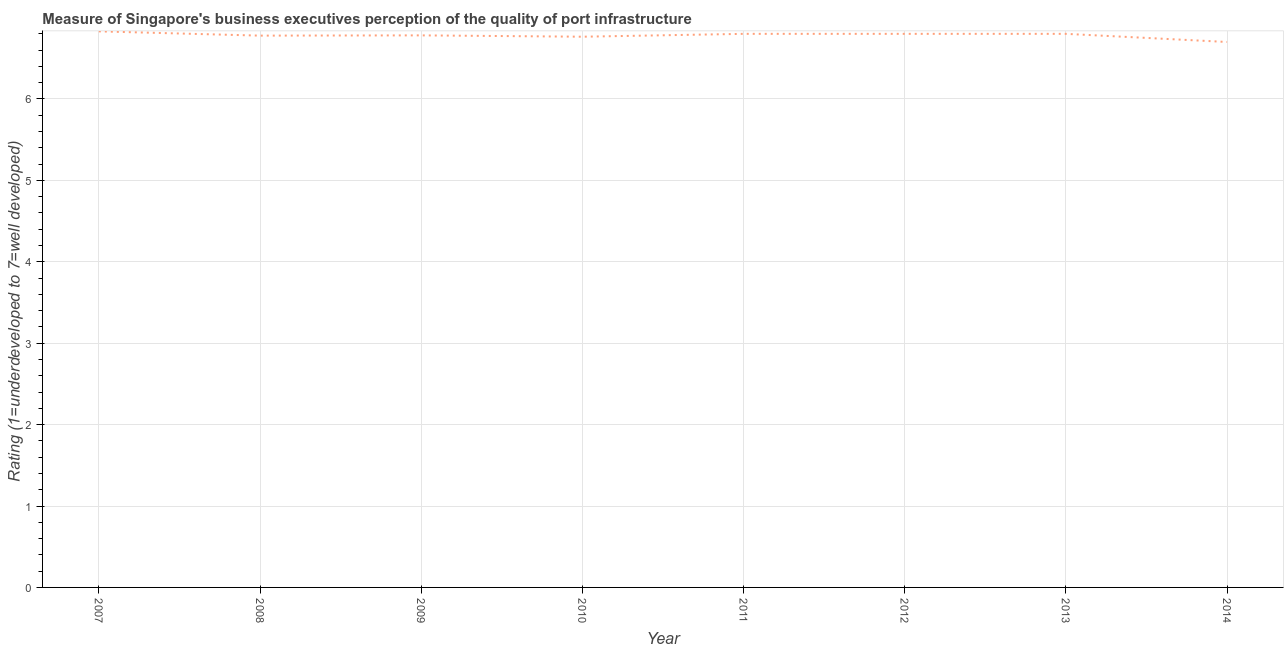Across all years, what is the maximum rating measuring quality of port infrastructure?
Offer a very short reply. 6.83. In which year was the rating measuring quality of port infrastructure maximum?
Ensure brevity in your answer.  2007. In which year was the rating measuring quality of port infrastructure minimum?
Offer a terse response. 2014. What is the sum of the rating measuring quality of port infrastructure?
Offer a very short reply. 54.25. What is the difference between the rating measuring quality of port infrastructure in 2009 and 2012?
Your response must be concise. -0.02. What is the average rating measuring quality of port infrastructure per year?
Make the answer very short. 6.78. What is the median rating measuring quality of port infrastructure?
Offer a very short reply. 6.79. Do a majority of the years between 2012 and 2014 (inclusive) have rating measuring quality of port infrastructure greater than 6 ?
Your answer should be very brief. Yes. What is the ratio of the rating measuring quality of port infrastructure in 2010 to that in 2012?
Keep it short and to the point. 0.99. Is the rating measuring quality of port infrastructure in 2007 less than that in 2012?
Your response must be concise. No. What is the difference between the highest and the second highest rating measuring quality of port infrastructure?
Your response must be concise. 0.03. What is the difference between the highest and the lowest rating measuring quality of port infrastructure?
Keep it short and to the point. 0.13. In how many years, is the rating measuring quality of port infrastructure greater than the average rating measuring quality of port infrastructure taken over all years?
Provide a succinct answer. 4. How many lines are there?
Offer a very short reply. 1. How many years are there in the graph?
Make the answer very short. 8. What is the difference between two consecutive major ticks on the Y-axis?
Keep it short and to the point. 1. Are the values on the major ticks of Y-axis written in scientific E-notation?
Give a very brief answer. No. Does the graph contain grids?
Provide a succinct answer. Yes. What is the title of the graph?
Offer a terse response. Measure of Singapore's business executives perception of the quality of port infrastructure. What is the label or title of the Y-axis?
Your response must be concise. Rating (1=underdeveloped to 7=well developed) . What is the Rating (1=underdeveloped to 7=well developed)  in 2007?
Your answer should be very brief. 6.83. What is the Rating (1=underdeveloped to 7=well developed)  of 2008?
Your answer should be very brief. 6.78. What is the Rating (1=underdeveloped to 7=well developed)  in 2009?
Give a very brief answer. 6.78. What is the Rating (1=underdeveloped to 7=well developed)  in 2010?
Your answer should be very brief. 6.76. What is the Rating (1=underdeveloped to 7=well developed)  of 2011?
Give a very brief answer. 6.8. What is the Rating (1=underdeveloped to 7=well developed)  in 2012?
Your answer should be compact. 6.8. What is the difference between the Rating (1=underdeveloped to 7=well developed)  in 2007 and 2008?
Give a very brief answer. 0.05. What is the difference between the Rating (1=underdeveloped to 7=well developed)  in 2007 and 2009?
Your response must be concise. 0.05. What is the difference between the Rating (1=underdeveloped to 7=well developed)  in 2007 and 2010?
Keep it short and to the point. 0.07. What is the difference between the Rating (1=underdeveloped to 7=well developed)  in 2007 and 2011?
Provide a short and direct response. 0.03. What is the difference between the Rating (1=underdeveloped to 7=well developed)  in 2007 and 2012?
Provide a short and direct response. 0.03. What is the difference between the Rating (1=underdeveloped to 7=well developed)  in 2007 and 2013?
Offer a very short reply. 0.03. What is the difference between the Rating (1=underdeveloped to 7=well developed)  in 2007 and 2014?
Provide a succinct answer. 0.13. What is the difference between the Rating (1=underdeveloped to 7=well developed)  in 2008 and 2009?
Your answer should be compact. -0. What is the difference between the Rating (1=underdeveloped to 7=well developed)  in 2008 and 2010?
Your answer should be very brief. 0.01. What is the difference between the Rating (1=underdeveloped to 7=well developed)  in 2008 and 2011?
Keep it short and to the point. -0.02. What is the difference between the Rating (1=underdeveloped to 7=well developed)  in 2008 and 2012?
Provide a short and direct response. -0.02. What is the difference between the Rating (1=underdeveloped to 7=well developed)  in 2008 and 2013?
Your response must be concise. -0.02. What is the difference between the Rating (1=underdeveloped to 7=well developed)  in 2008 and 2014?
Provide a succinct answer. 0.08. What is the difference between the Rating (1=underdeveloped to 7=well developed)  in 2009 and 2010?
Offer a terse response. 0.02. What is the difference between the Rating (1=underdeveloped to 7=well developed)  in 2009 and 2011?
Ensure brevity in your answer.  -0.02. What is the difference between the Rating (1=underdeveloped to 7=well developed)  in 2009 and 2012?
Offer a very short reply. -0.02. What is the difference between the Rating (1=underdeveloped to 7=well developed)  in 2009 and 2013?
Offer a terse response. -0.02. What is the difference between the Rating (1=underdeveloped to 7=well developed)  in 2009 and 2014?
Keep it short and to the point. 0.08. What is the difference between the Rating (1=underdeveloped to 7=well developed)  in 2010 and 2011?
Your response must be concise. -0.04. What is the difference between the Rating (1=underdeveloped to 7=well developed)  in 2010 and 2012?
Your answer should be compact. -0.04. What is the difference between the Rating (1=underdeveloped to 7=well developed)  in 2010 and 2013?
Keep it short and to the point. -0.04. What is the difference between the Rating (1=underdeveloped to 7=well developed)  in 2010 and 2014?
Offer a terse response. 0.06. What is the difference between the Rating (1=underdeveloped to 7=well developed)  in 2011 and 2012?
Provide a short and direct response. 0. What is the difference between the Rating (1=underdeveloped to 7=well developed)  in 2011 and 2014?
Give a very brief answer. 0.1. What is the difference between the Rating (1=underdeveloped to 7=well developed)  in 2012 and 2013?
Your response must be concise. 0. What is the difference between the Rating (1=underdeveloped to 7=well developed)  in 2012 and 2014?
Your answer should be very brief. 0.1. What is the ratio of the Rating (1=underdeveloped to 7=well developed)  in 2007 to that in 2008?
Give a very brief answer. 1.01. What is the ratio of the Rating (1=underdeveloped to 7=well developed)  in 2007 to that in 2010?
Offer a terse response. 1.01. What is the ratio of the Rating (1=underdeveloped to 7=well developed)  in 2007 to that in 2012?
Keep it short and to the point. 1. What is the ratio of the Rating (1=underdeveloped to 7=well developed)  in 2007 to that in 2013?
Offer a terse response. 1. What is the ratio of the Rating (1=underdeveloped to 7=well developed)  in 2007 to that in 2014?
Your answer should be very brief. 1.02. What is the ratio of the Rating (1=underdeveloped to 7=well developed)  in 2008 to that in 2009?
Your answer should be compact. 1. What is the ratio of the Rating (1=underdeveloped to 7=well developed)  in 2008 to that in 2011?
Your answer should be compact. 1. What is the ratio of the Rating (1=underdeveloped to 7=well developed)  in 2008 to that in 2013?
Your answer should be compact. 1. What is the ratio of the Rating (1=underdeveloped to 7=well developed)  in 2009 to that in 2010?
Provide a succinct answer. 1. What is the ratio of the Rating (1=underdeveloped to 7=well developed)  in 2009 to that in 2012?
Keep it short and to the point. 1. What is the ratio of the Rating (1=underdeveloped to 7=well developed)  in 2009 to that in 2013?
Provide a succinct answer. 1. What is the ratio of the Rating (1=underdeveloped to 7=well developed)  in 2009 to that in 2014?
Provide a succinct answer. 1.01. What is the ratio of the Rating (1=underdeveloped to 7=well developed)  in 2010 to that in 2012?
Make the answer very short. 0.99. What is the ratio of the Rating (1=underdeveloped to 7=well developed)  in 2010 to that in 2013?
Offer a terse response. 0.99. What is the ratio of the Rating (1=underdeveloped to 7=well developed)  in 2010 to that in 2014?
Your answer should be compact. 1.01. What is the ratio of the Rating (1=underdeveloped to 7=well developed)  in 2011 to that in 2012?
Provide a succinct answer. 1. What is the ratio of the Rating (1=underdeveloped to 7=well developed)  in 2011 to that in 2013?
Provide a succinct answer. 1. 